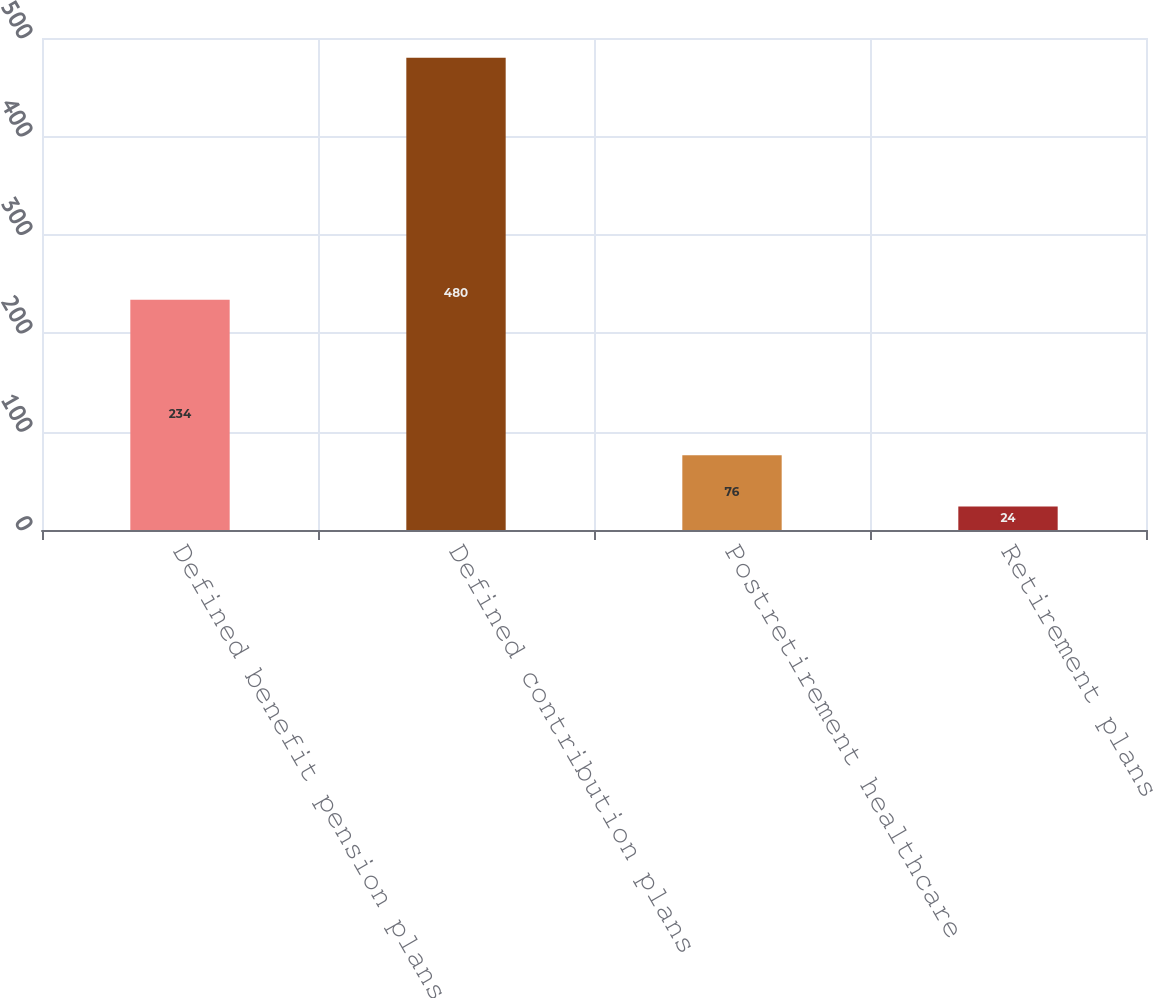Convert chart. <chart><loc_0><loc_0><loc_500><loc_500><bar_chart><fcel>Defined benefit pension plans<fcel>Defined contribution plans<fcel>Postretirement healthcare<fcel>Retirement plans<nl><fcel>234<fcel>480<fcel>76<fcel>24<nl></chart> 